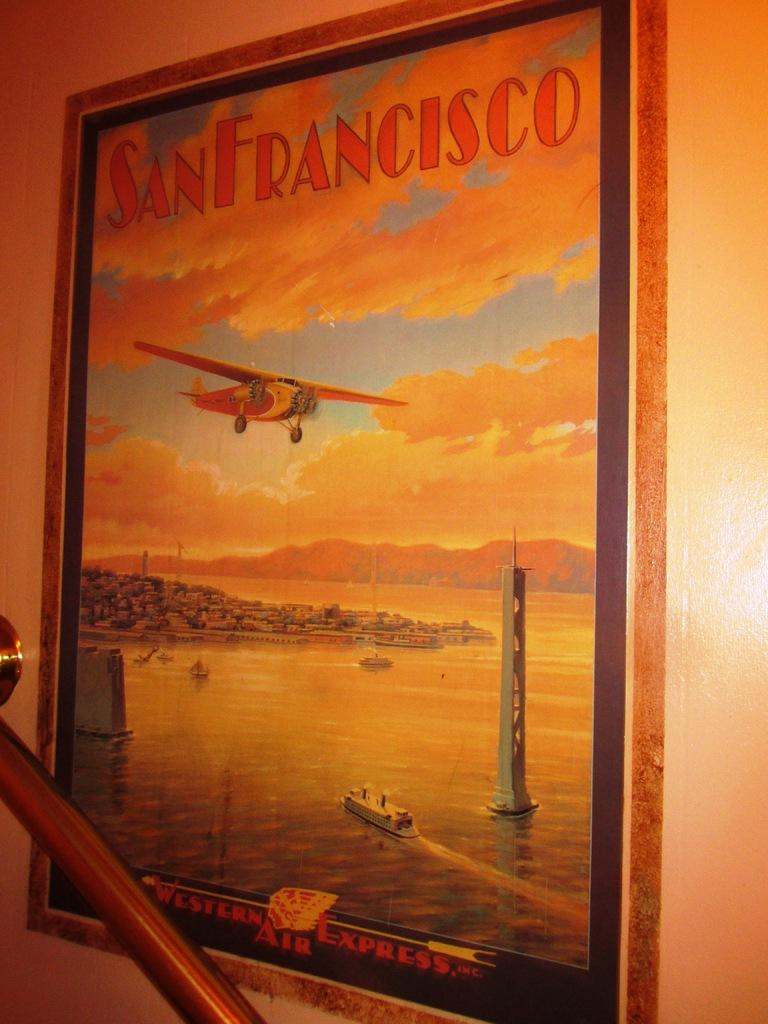What is present on the wall in the image? There is a frame on the wall. What can be seen on the frame? There is text on the frame. What is depicted in the image? There is an airplane, the sky, the sea, a ship, and a tower in the image. Where is the nest located in the image? There is no nest present in the image. What is the mass of the tower depicted in the image? The mass of the tower cannot be determined from the image alone. --- Facts: 1. There is a person sitting on a chair in the image. 2. The person is holding a book. 3. The book has a blue cover. 4. There is a table next to the chair. 5. There is a lamp on the table. Absurd Topics: elephant, ocean, mountain Conversation: What is the person in the image doing? The person is sitting on a chair in the image. What is the person holding? The person is holding a book. What color is the book's cover? The book has a blue cover. What is located next to the chair? There is a table next to the chair. What is on the table? There is a lamp on the table. Reasoning: Let's think step by step in order to produce the conversation. We start by identifying the main subject in the image, which is the person sitting on a chair. Then, we expand the conversation to include other items that are also visible, such as the book, the table, and the lamp. Each question is designed to elicit a specific detail about the image that is known from the provided facts. Absurd Question/Answer: Can you see an elephant swimming in the ocean in the image? No, there is no elephant or ocean present in the image. 